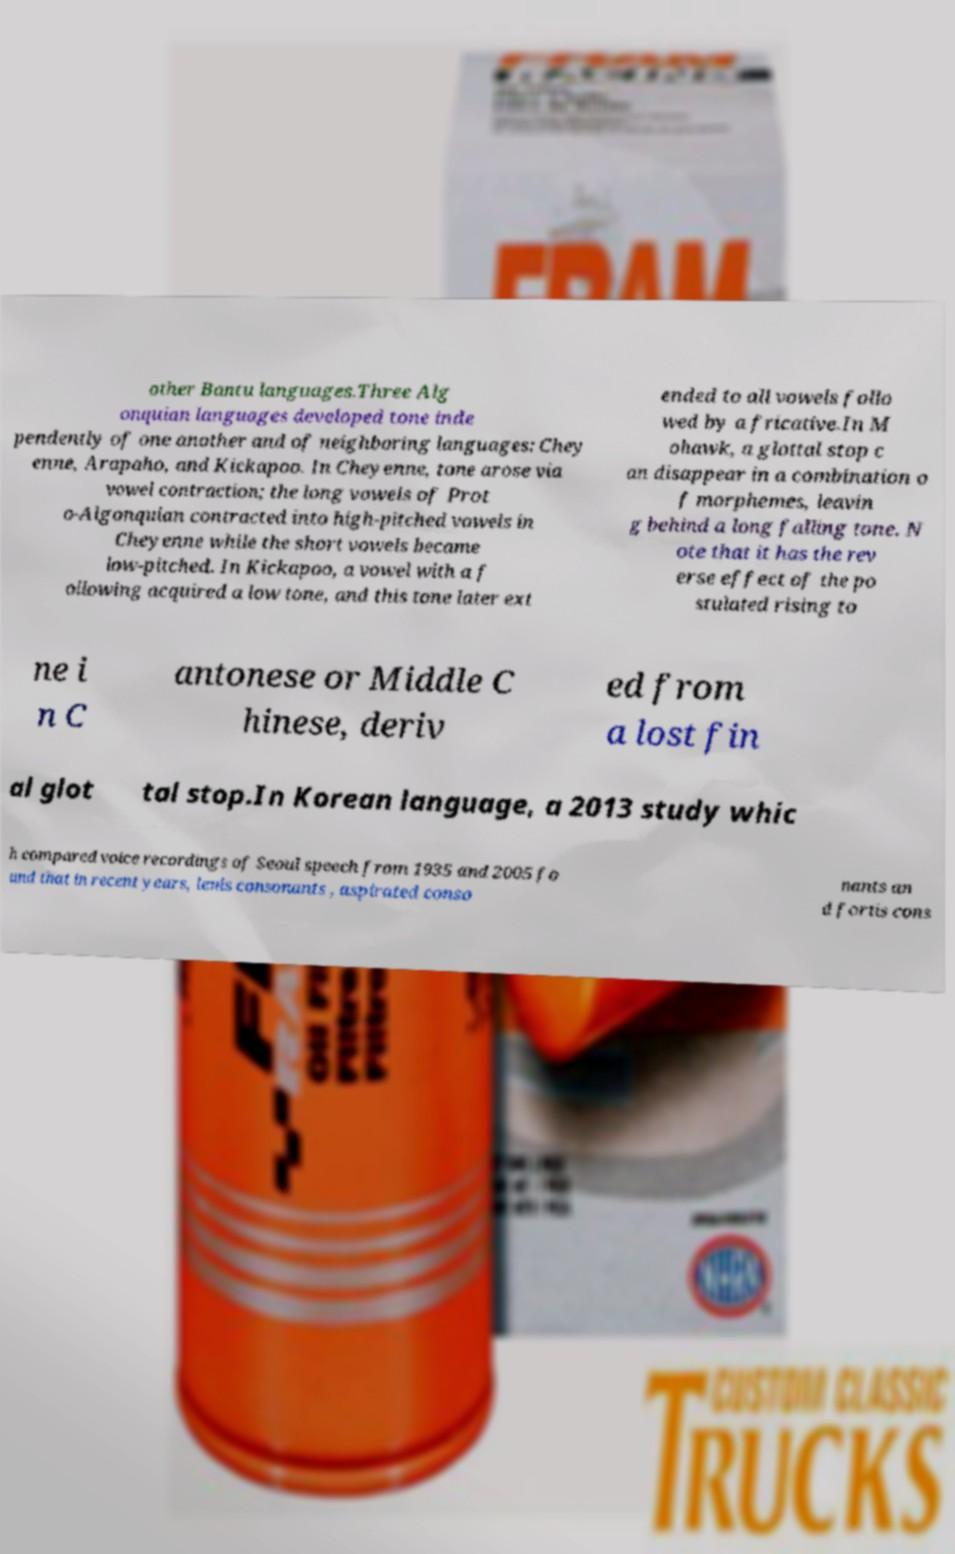I need the written content from this picture converted into text. Can you do that? other Bantu languages.Three Alg onquian languages developed tone inde pendently of one another and of neighboring languages: Chey enne, Arapaho, and Kickapoo. In Cheyenne, tone arose via vowel contraction; the long vowels of Prot o-Algonquian contracted into high-pitched vowels in Cheyenne while the short vowels became low-pitched. In Kickapoo, a vowel with a f ollowing acquired a low tone, and this tone later ext ended to all vowels follo wed by a fricative.In M ohawk, a glottal stop c an disappear in a combination o f morphemes, leavin g behind a long falling tone. N ote that it has the rev erse effect of the po stulated rising to ne i n C antonese or Middle C hinese, deriv ed from a lost fin al glot tal stop.In Korean language, a 2013 study whic h compared voice recordings of Seoul speech from 1935 and 2005 fo und that in recent years, lenis consonants , aspirated conso nants an d fortis cons 